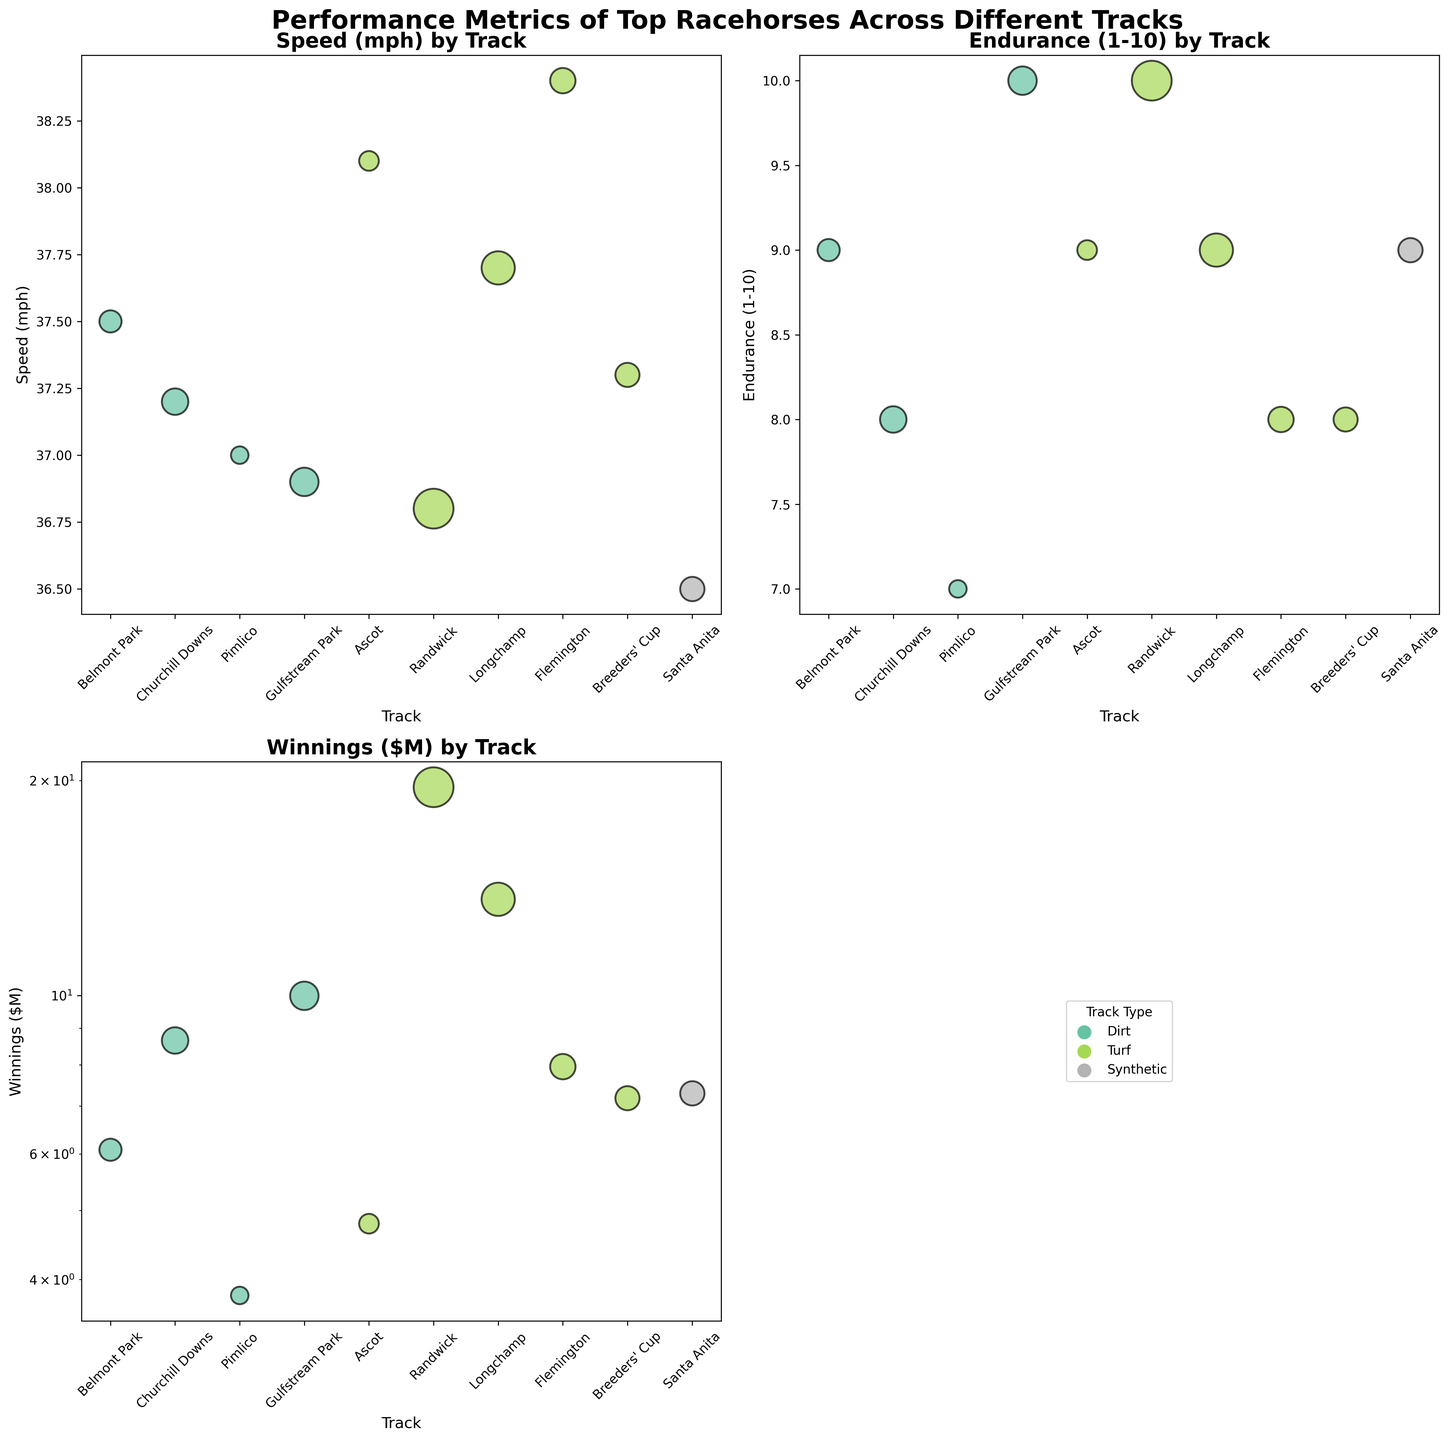what's the title of the figure? The title is located at the top center of the figure. It reads: "Performance Metrics of Top Racehorses Across Different Tracks".
Answer: Performance Metrics of Top Racehorses Across Different Tracks How many different track types are represented in the legend? The legend in the bottom right subplot shows distinct markers for each track type. By counting these markers, you can determine the number.
Answer: 3 Which horse has the highest speed according to this figure? In the subplot titled 'Speed (mph) by Track', the horse with the highest y-axis value determines the highest speed. This corresponds to Frankel at Ascot.
Answer: Frankel Which track type is associated with the largest bubble in the 'Winnings ($M) by Track' subplot? Locate the largest bubble (i.e., the bubble with the greatest diameter) in the 'Winnings ($M)' subplot, and identify its color. Then, match this color in the legend to find the track type.
Answer: Turf What is the average endurance of the racehorses running at turf tracks? First, find all the endurance values for horses running on turf tracks. These are 9 (Frankel), 10 (Winx), 9 (Enable), 8 (Black Caviar), and 8 (Goldikova). Sum these values (9 + 10 + 9 + 8 + 8) = 44, then divide by the number of values (5).
Answer: 8.8 Which track has the most significant disparity between speed and winnings? Evaluate the 'Speed (mph)' and 'Winnings ($M)' subplots. Identify the track where the position of the speed value is either significantly higher or lower compared to its winnings value, and calculate the differences to confirm. Randwick with Winx shows significant disparity (speed: 36.8, winnings: 19.58).
Answer: Randwick How many horses have an endurance rating of 9? Check the 'Endurance (1-10) by Track' subplot, and count the number of points at the y-value of 9. These horses are Secretariat, Frankel, Enable, and Zenyatta, totaling 4.
Answer: 4 What is the color representing horses running on dirt tracks? Examine the legend in the bottom right subplot to find the color assigned to 'Dirt' track type.
Answer: A specific color (as represented in the legend) Which track's horse has the highest winnings in the Turf category? In the 'Winnings ($M) by Track' subplot, find the highest bubble among those colored to represent turf tracks. This bubble is associated with Winx at Randwick with winnings of $19.58M.
Answer: Randwick 